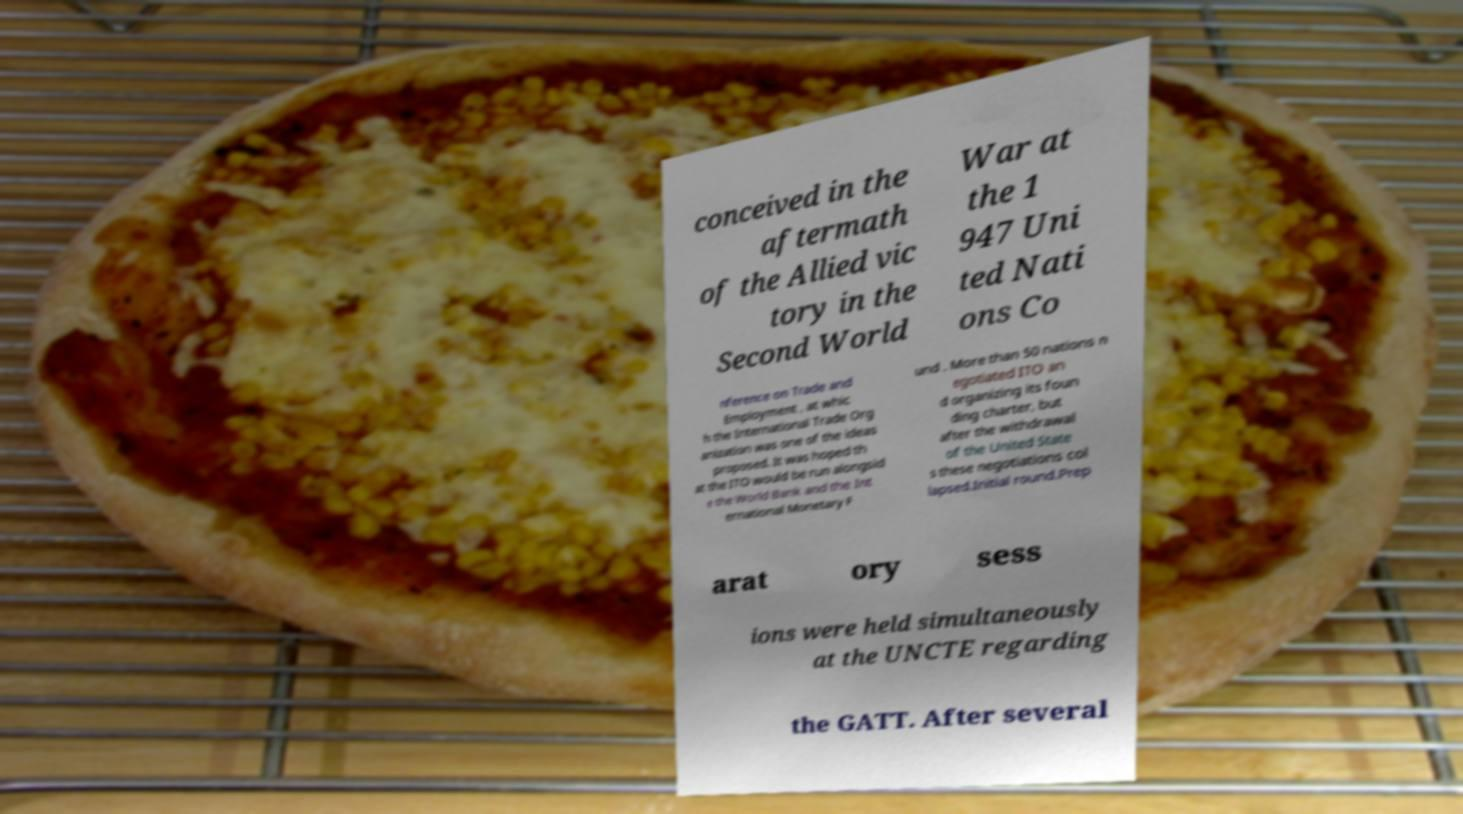For documentation purposes, I need the text within this image transcribed. Could you provide that? conceived in the aftermath of the Allied vic tory in the Second World War at the 1 947 Uni ted Nati ons Co nference on Trade and Employment , at whic h the International Trade Org anization was one of the ideas proposed. It was hoped th at the ITO would be run alongsid e the World Bank and the Int ernational Monetary F und . More than 50 nations n egotiated ITO an d organizing its foun ding charter, but after the withdrawal of the United State s these negotiations col lapsed.Initial round.Prep arat ory sess ions were held simultaneously at the UNCTE regarding the GATT. After several 